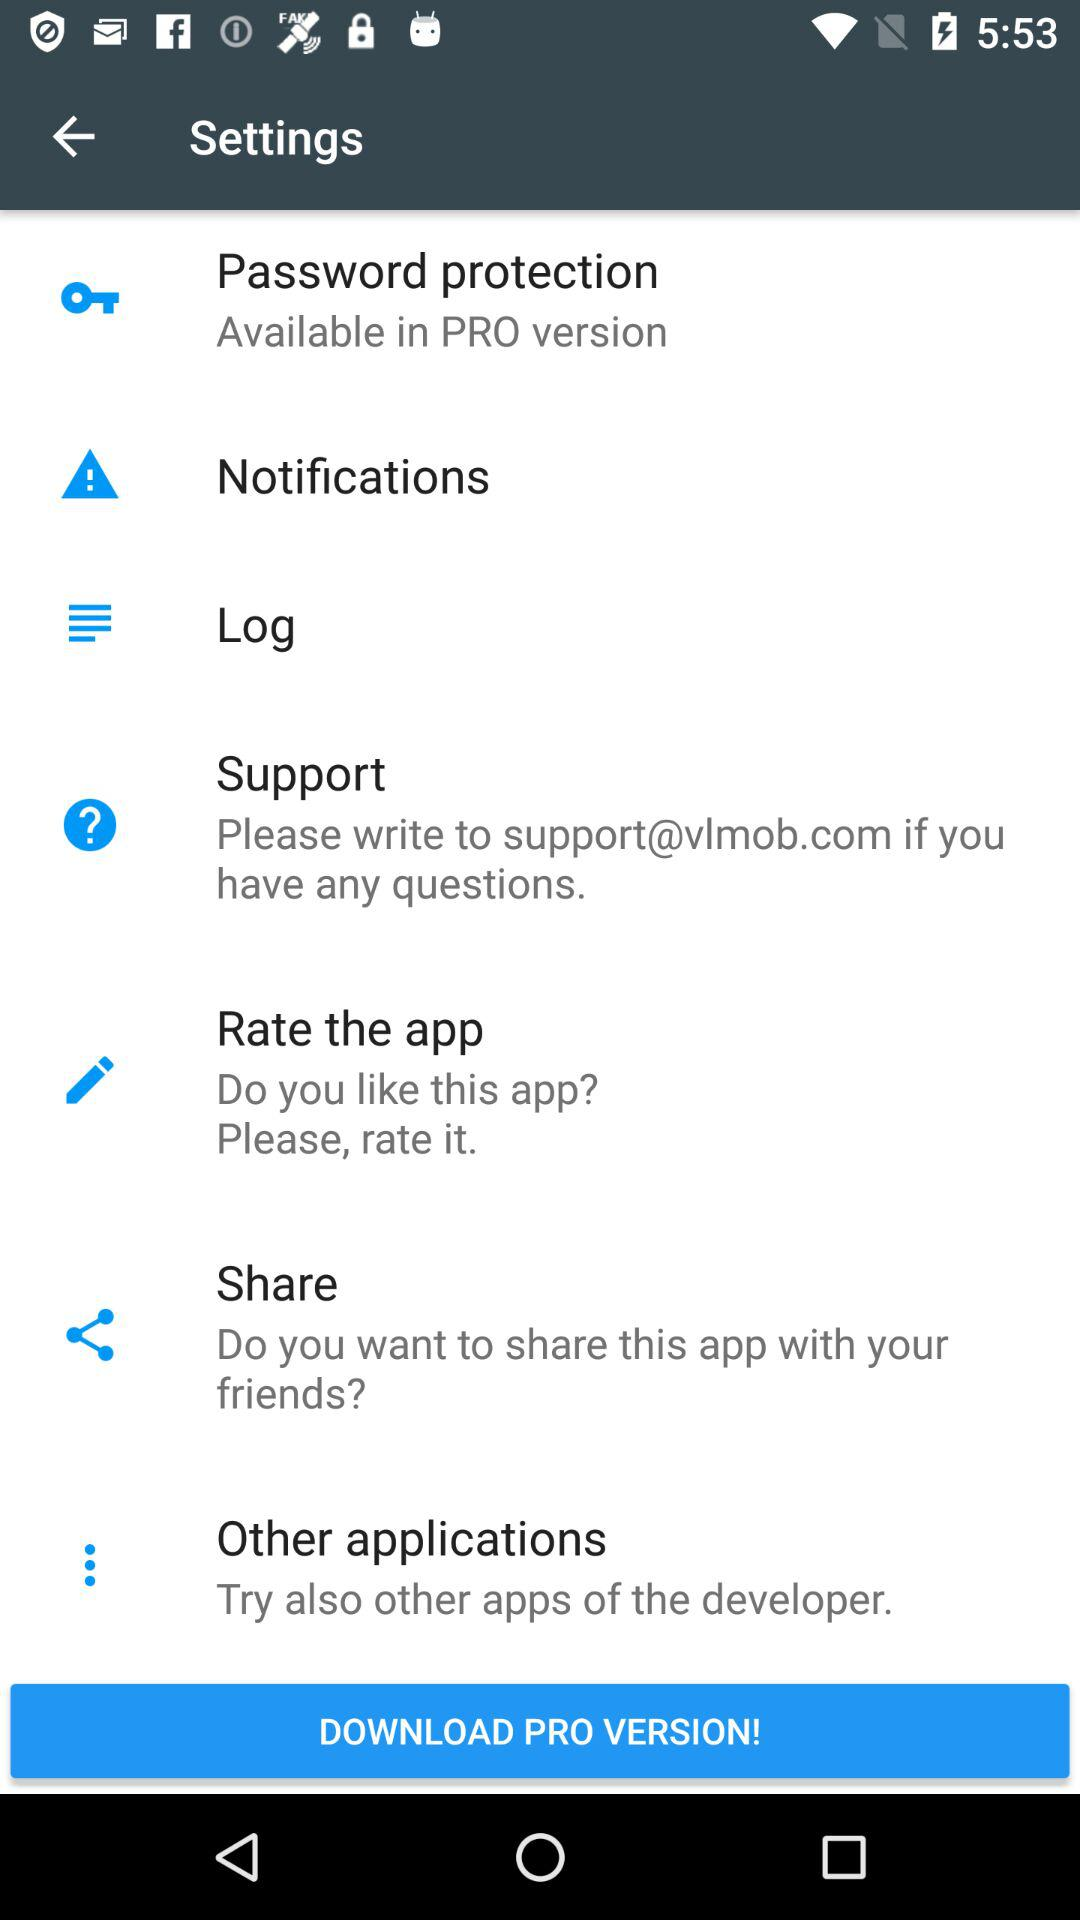What is the support email ID for any query? The support email ID for any query is support@vlmob.com. 